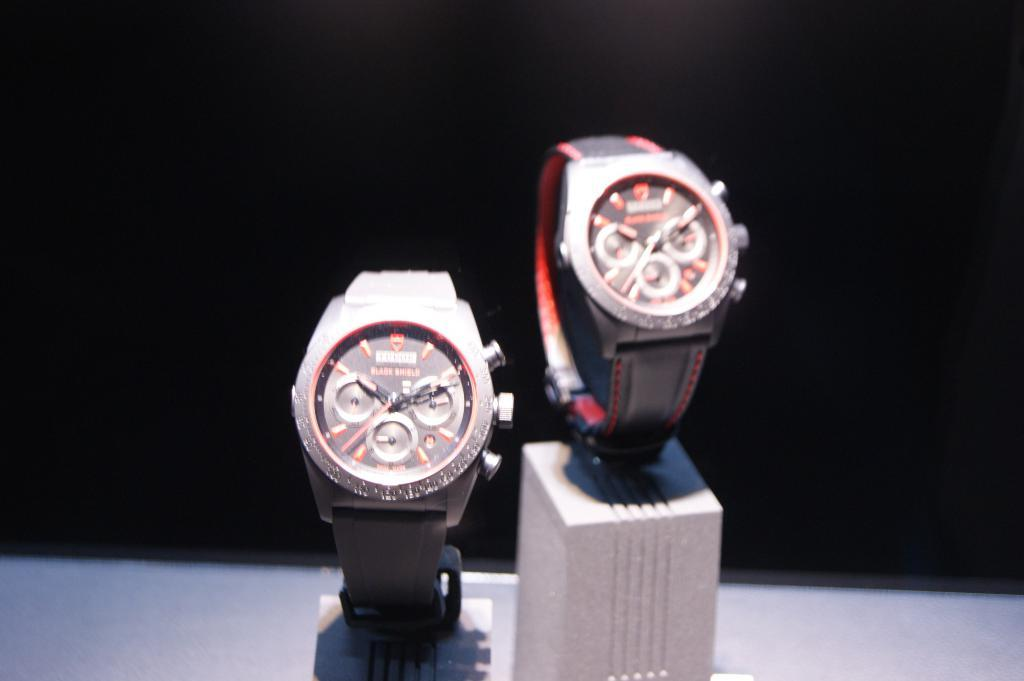What objects are present on the table in the image? There are two hand watches on the table in the image. What type of objects are the hand watches? The hand watches are timekeeping devices. What can be observed about the background of the image? The background of the image is dark. What type of acoustics can be heard in the image? There is no information about acoustics in the image, as it only features two hand watches on a table with a dark background. 